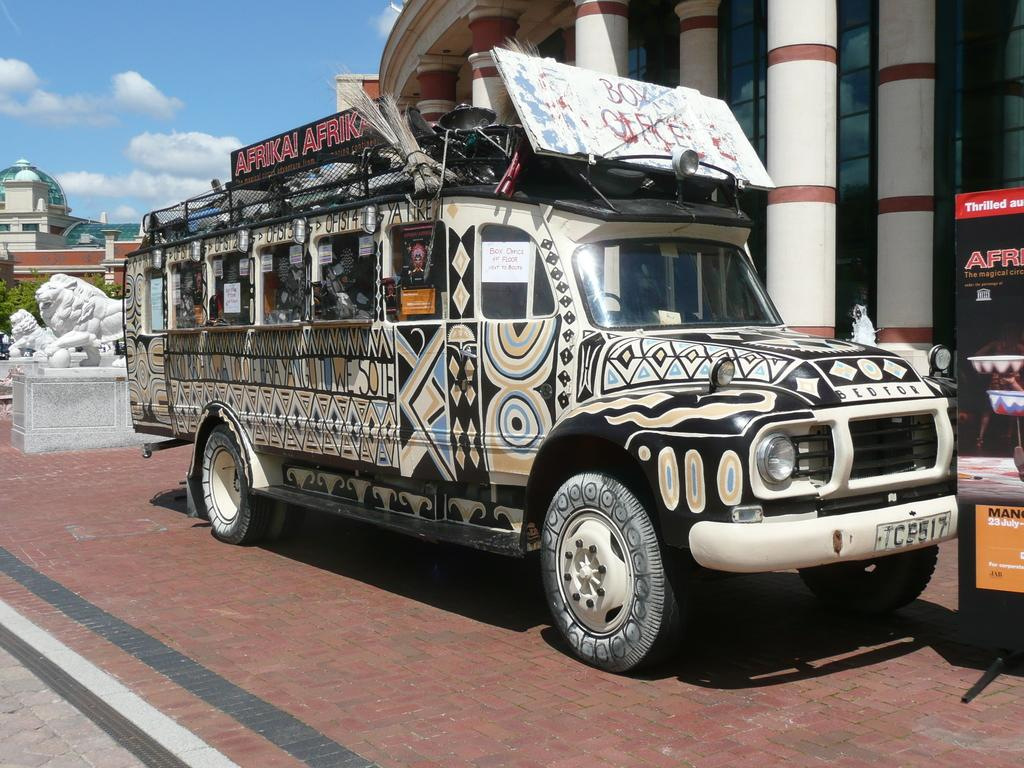What is the main subject in the center of the image? There is a truck in the center of the image. What can be seen on the right side of the image? There is a banner on the right side of the image. What is located on the left side of the image? There are sculptures on the left side of the image. What is visible in the background of the image? There are buildings and trees in the background of the image. How would you describe the weather in the image? The sky is sunny, suggesting a clear and bright day. What type of gun is being used by the sculpture in the image? There is no gun present in the image; it features a truck, a banner, sculptures, buildings, trees, and a sunny sky. 